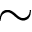Convert formula to latex. <formula><loc_0><loc_0><loc_500><loc_500>\sim</formula> 